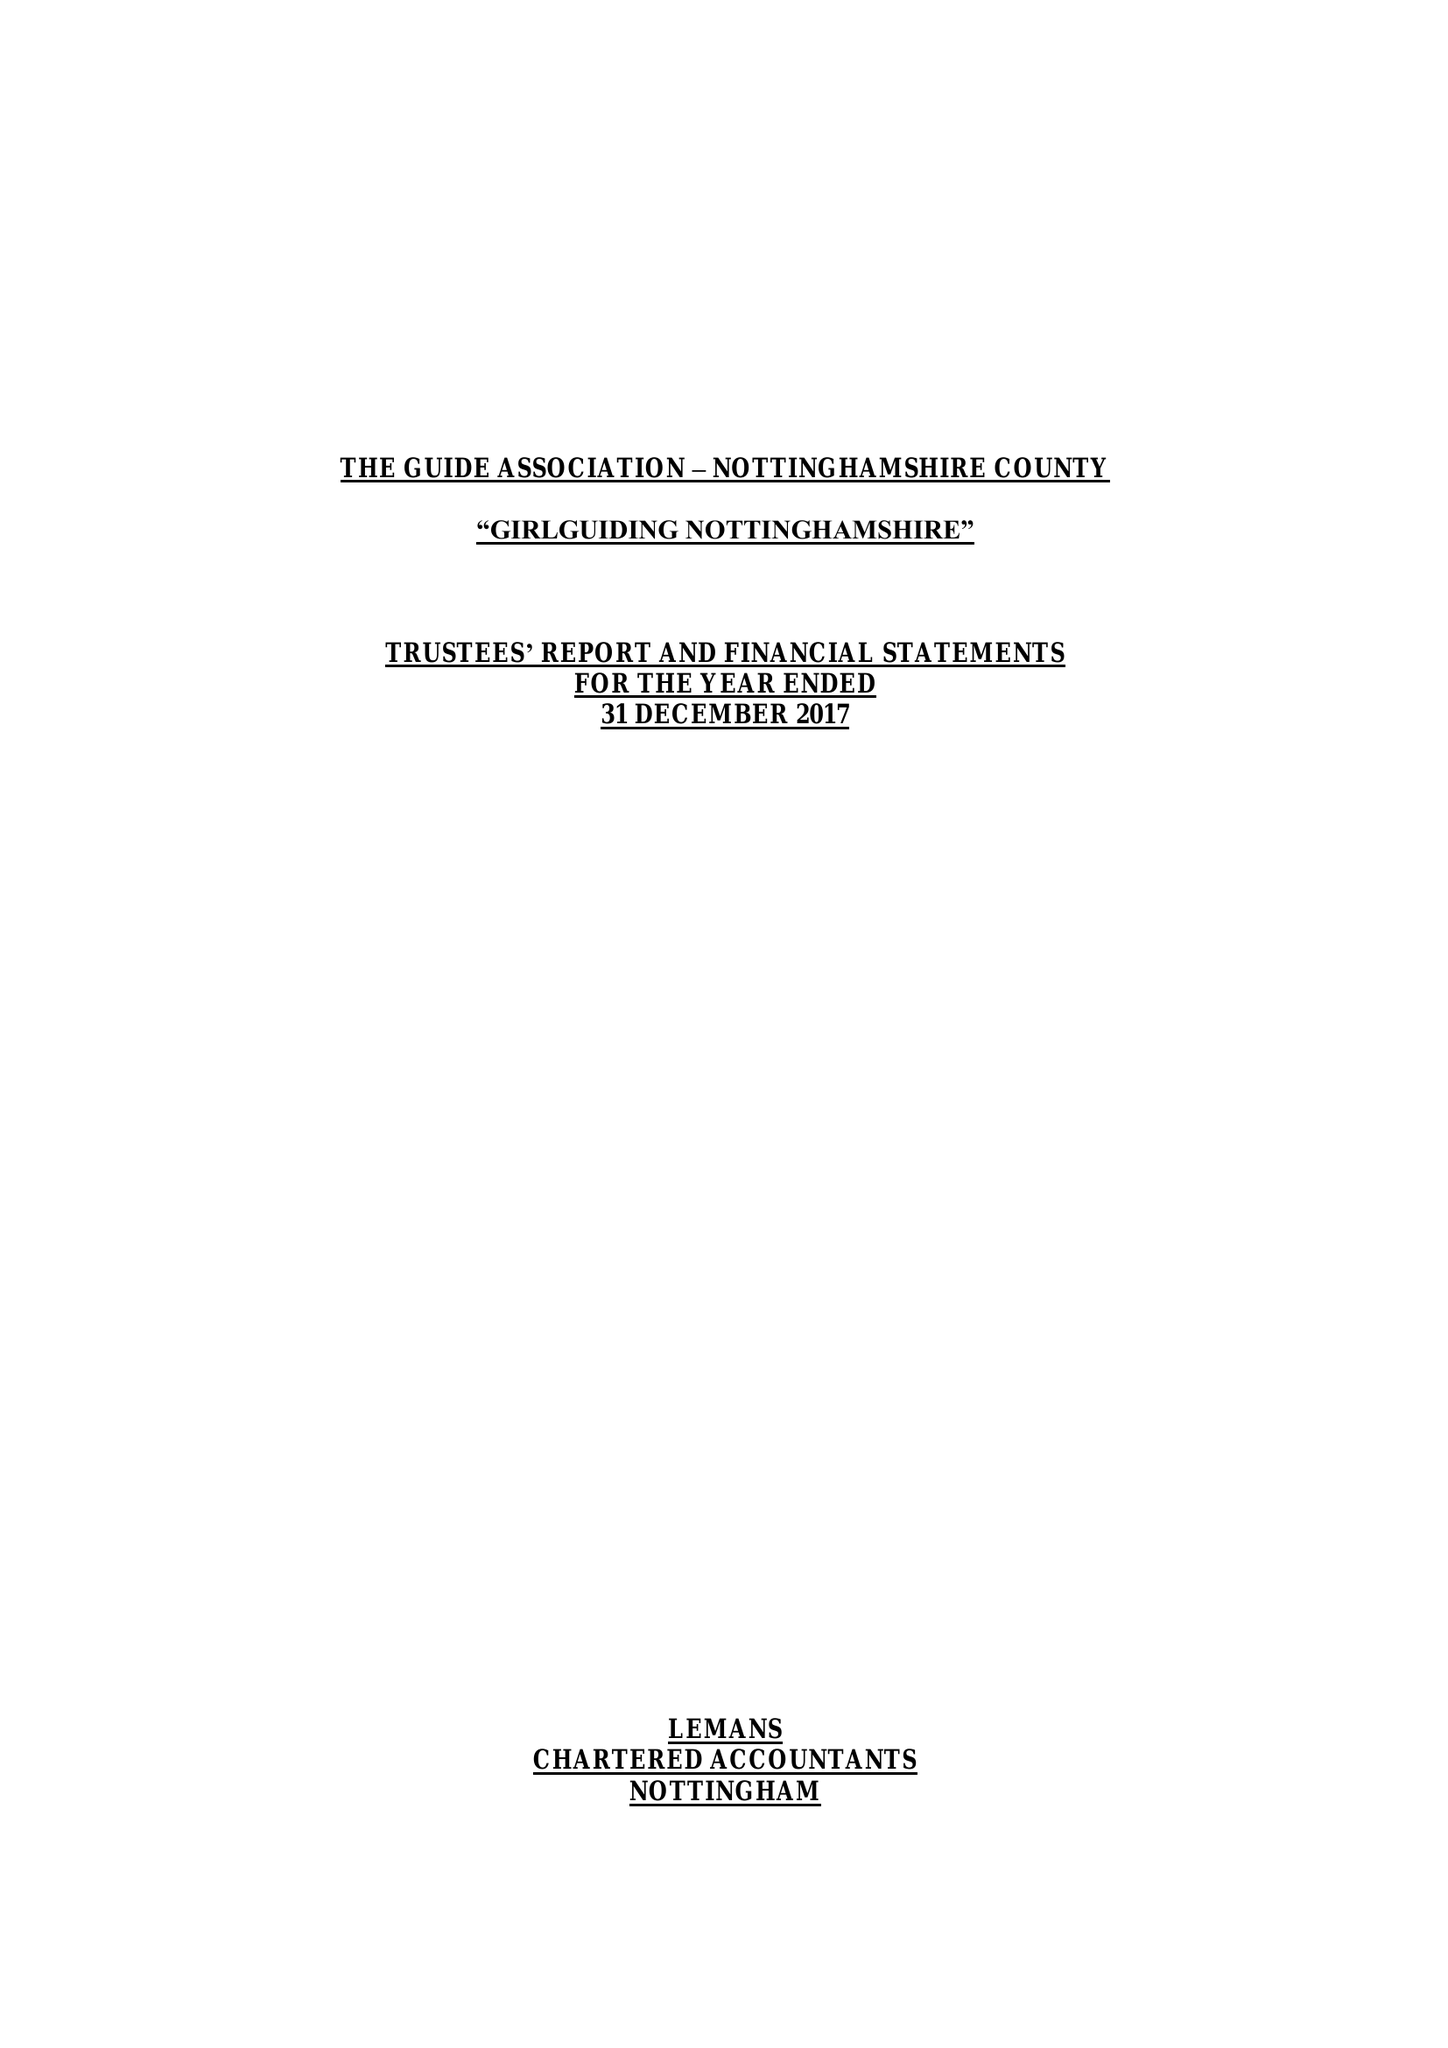What is the value for the address__street_line?
Answer the question using a single word or phrase. 16-18 BURTON ROAD 